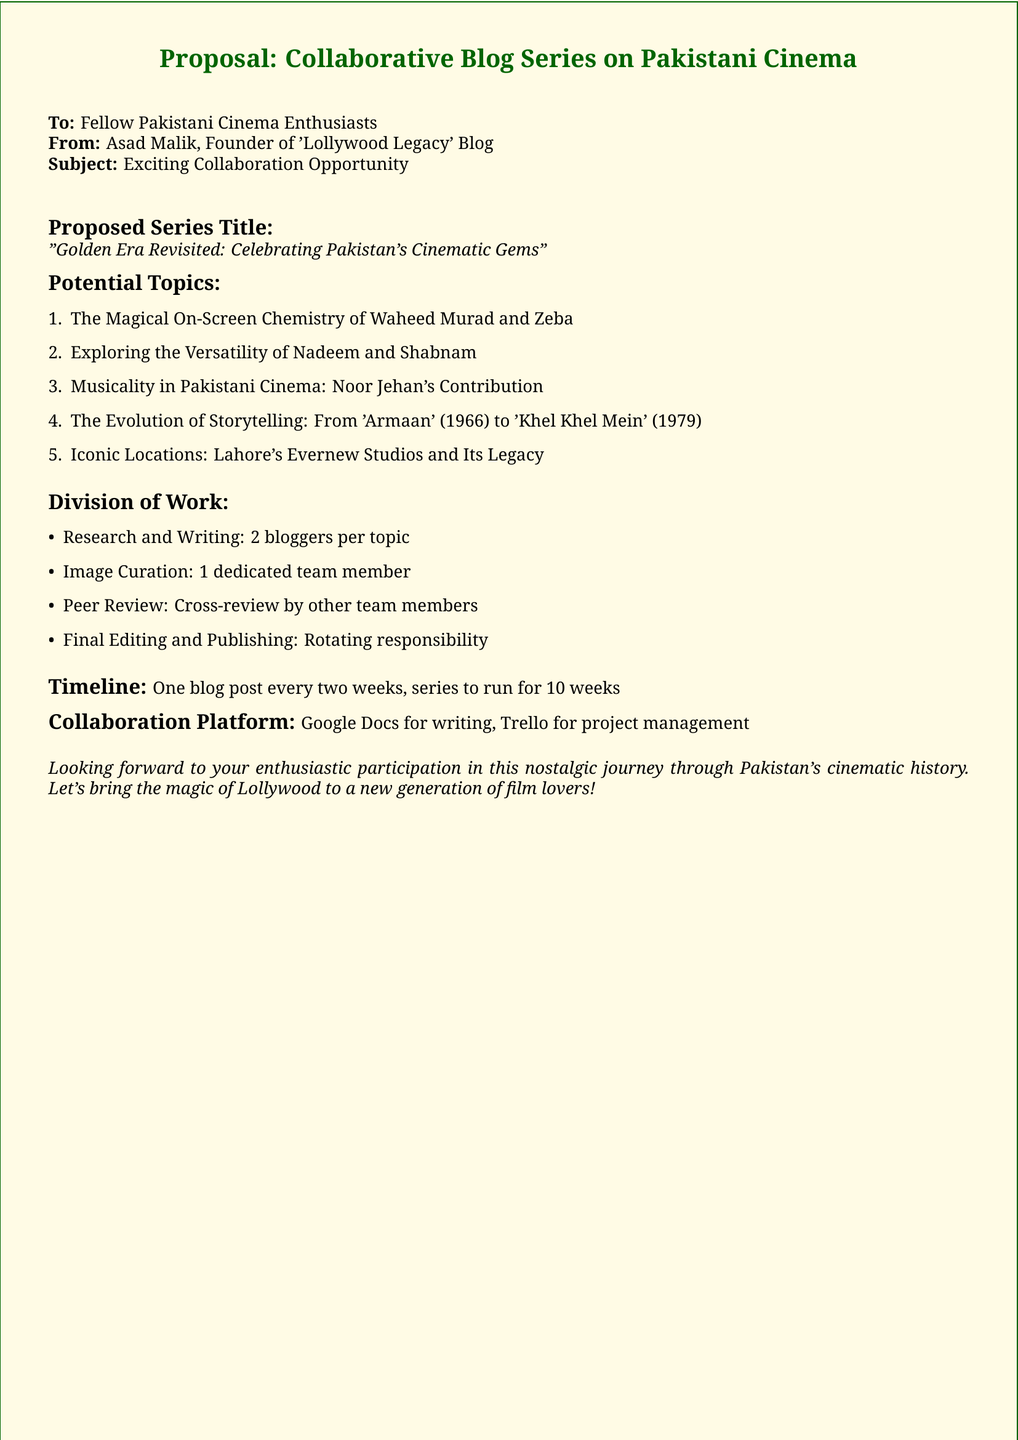What is the series title? The series title is explicitly mentioned in the document as part of the proposal.
Answer: "Golden Era Revisited: Celebrating Pakistan's Cinematic Gems" Who is the sender of the proposal? The sender is identified at the beginning of the document, providing their name and blog.
Answer: Asad Malik How many topics are proposed in the series? The total number of potential topics is listed in the document.
Answer: Five What is the main collaboration platform for writing? The document specifies the platform intended for collaborative writing efforts.
Answer: Google Docs What is the timeline for the blog series? The timeline is presented in the document, outlining the frequency of posts.
Answer: One blog post every two weeks What is the role of the image curator? The specific role related to images is mentioned in the division of work section.
Answer: 1 dedicated team member How long will the series run? The duration of the series is indicated in the timeline section of the document.
Answer: 10 weeks What is the focus of the blog series? The main focus of the blog series is summarized in the title and introduction.
Answer: Celebrating Pakistan's Cinematic Gems How many bloggers will research and write per topic? The document specifies how many bloggers are assigned to research and writing for each topic.
Answer: 2 bloggers per topic 